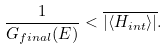Convert formula to latex. <formula><loc_0><loc_0><loc_500><loc_500>\frac { 1 } { G _ { f i n a l } ( E ) } < \overline { | \langle H _ { i n t } \rangle | } .</formula> 